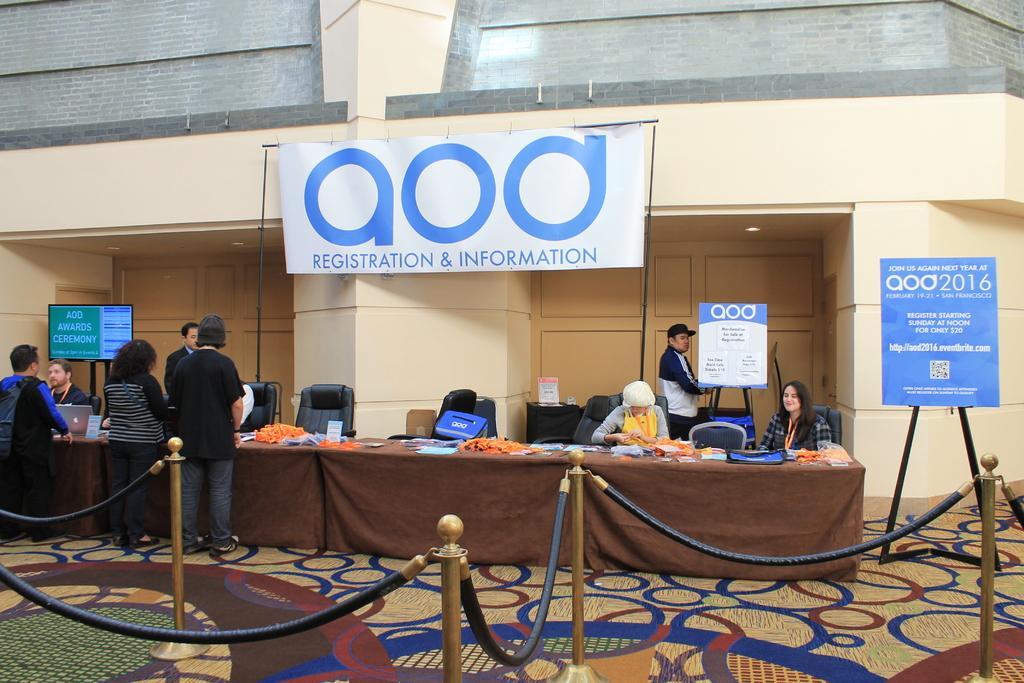Please provide a concise description of this image. There is a fence on a floor, on which there is a carpet. In the background, there are three persons standing. In front of them, there is a table, on which there are some objects. Beside this table, there are persons sitting and there are two persons standing. There are hoardings, a screen and a wall. 